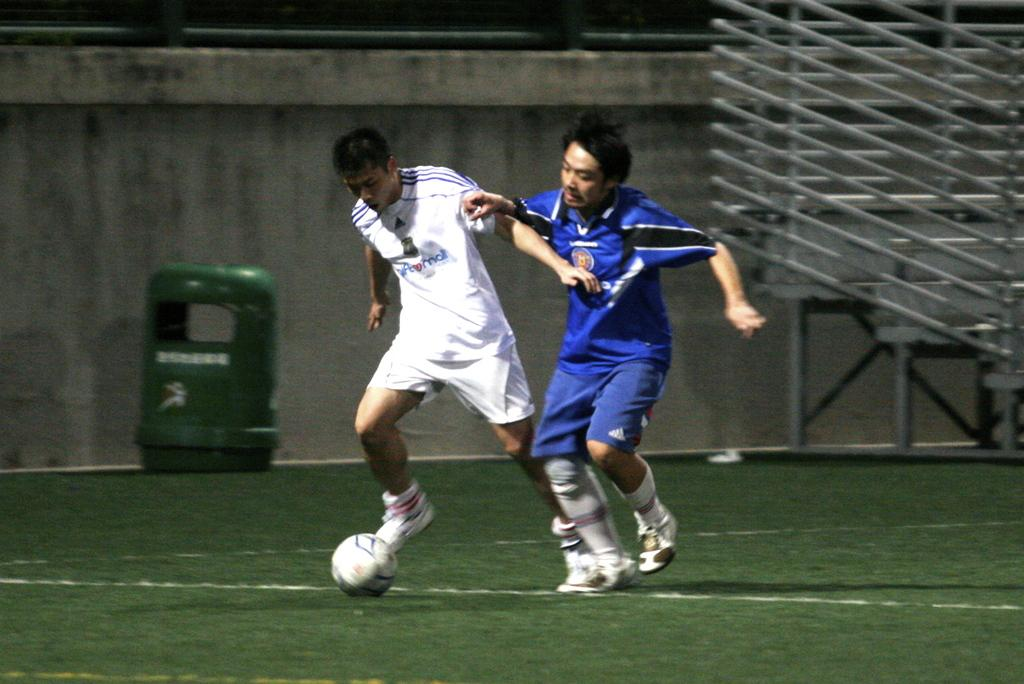How many people are in the image? There are two persons in the image. What are the two persons doing? The two persons are playing football. What is the surface they are playing on? The ground is covered with grass. What objects can be seen in the background of the image? There is a wall and a rod in the background of the image. What additional object is present in the image? There is a bin in the image. What type of lunch is being served in the image? There is no indication of lunch being served in the image; it features two people playing football on a grassy surface. What health benefits can be gained from the activity depicted in the image? While playing football can have health benefits, the question is not directly answerable from the image, as it does not specifically address the health benefits of the activity. 